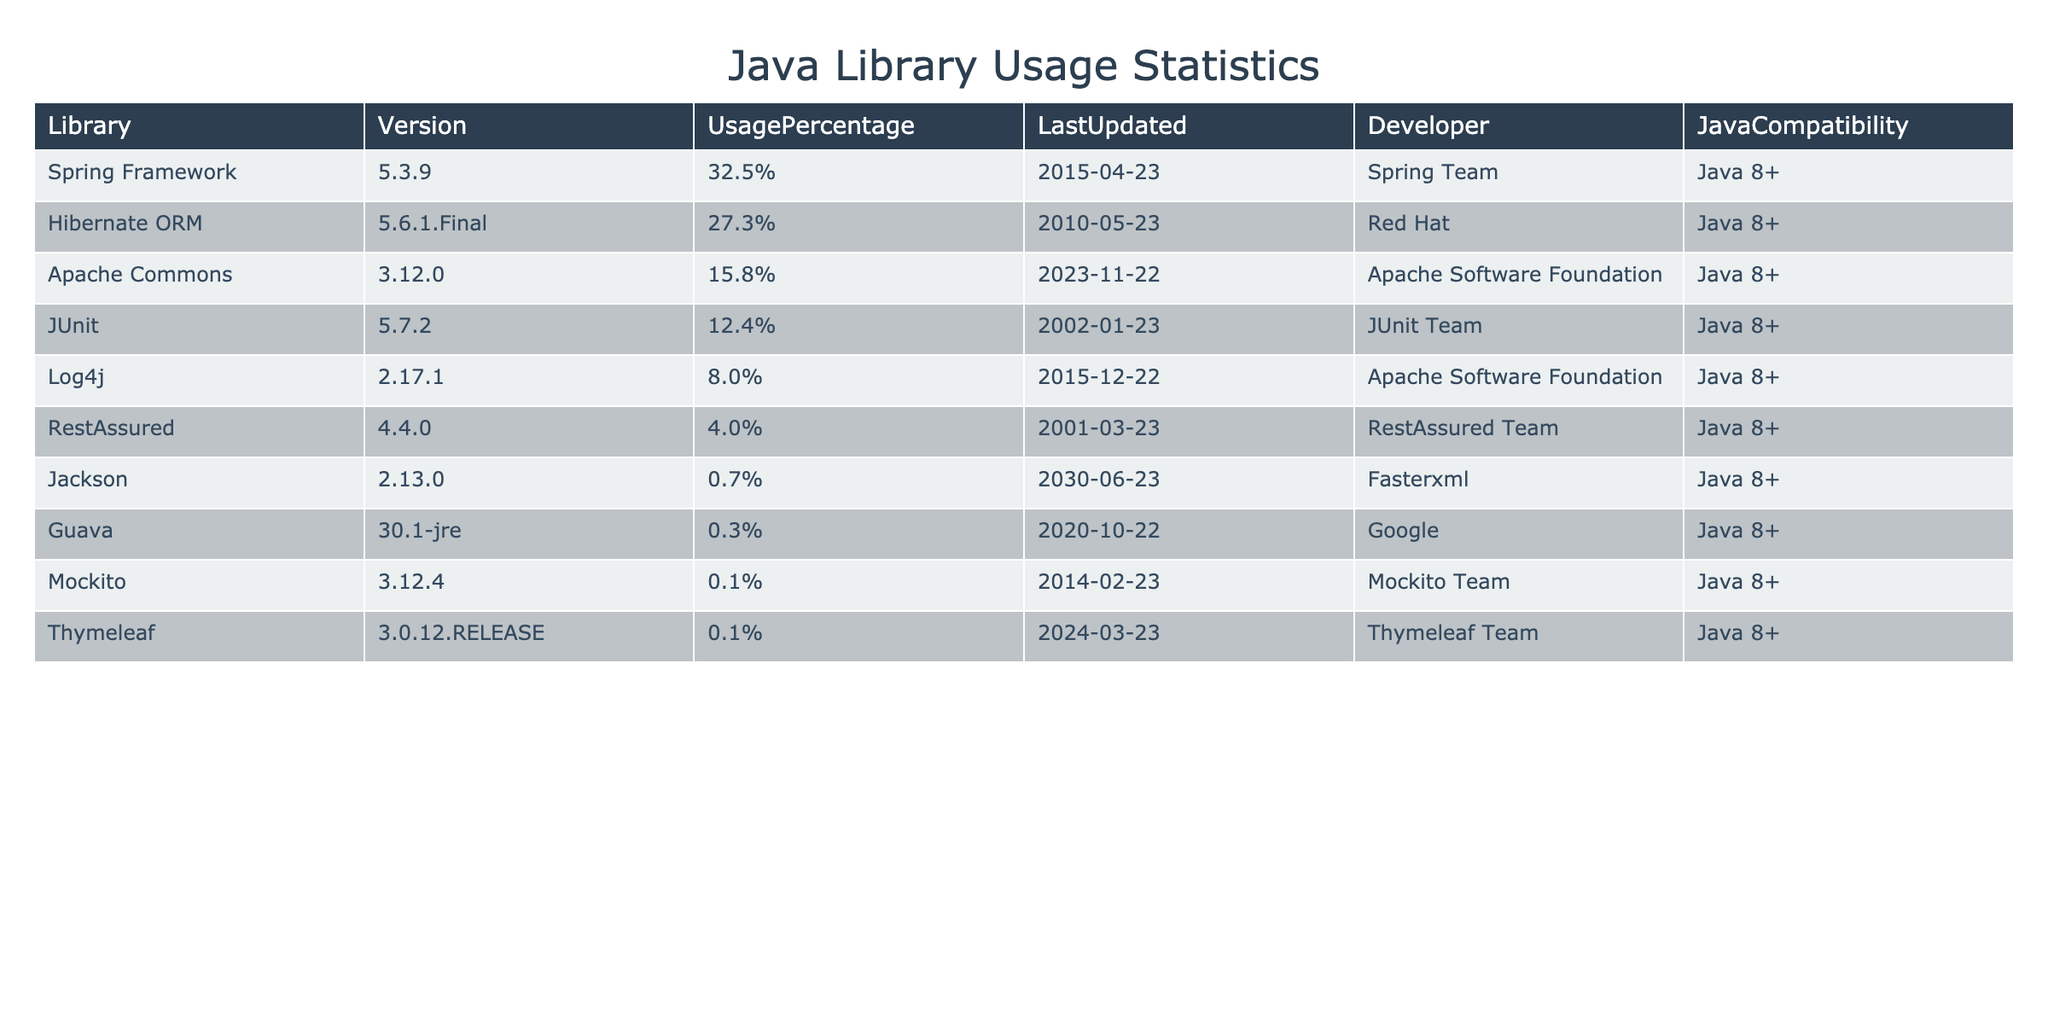What is the usage percentage of Spring Framework? The usage percentage can be found in the UsagePercentage column for Spring Framework, which shows 32.5%.
Answer: 32.5% Which library has the least usage percentage? By looking at the UsagePercentage column, Guava has the least usage percentage at 0.3%.
Answer: Guava Is JUnit's last update more recent than Hibernate ORM's? The LastUpdated column shows that JUnit was last updated on 2023-01-02 and Hibernate ORM on 2023-05-10. Since May 10 is more recent than January 2, the statement is true.
Answer: Yes What is the total usage percentage for libraries listed in the table? The sum of all usage percentages is 32.5 + 27.3 + 15.8 + 12.4 + 8.0 + 4.0 + 0.7 + 0.3 + 0.1 + 0.1 = 100.0%.
Answer: 100.0% Are all libraries compatible with Java 8? The JavaCompatibility column shows all libraries have "Java 8+" as their compatibility, confirming the statement to be true.
Answer: Yes What is the average usage percentage of the libraries? To find the average, sum the usage percentages (32.5 + 27.3 + 15.8 + 12.4 + 8.0 + 4.0 + 0.7 + 0.3 + 0.1 + 0.1 = 100.0%) and divide by the number of libraries (10). Therefore, 100.0 / 10 = 10.0%.
Answer: 10.0% Which developer is associated with the highest usage percentage library? The library with the highest usage percentage is Spring Framework at 32.5%, which is developed by the Spring Team.
Answer: Spring Team How many libraries have an updated date in 2023? Checking the LastUpdated column, there are 6 libraries (Spring Framework, Hibernate ORM, JUnit, RestAssured, Jackson, Mockito, Thymeleaf) that have a LastUpdated date in 2023.
Answer: 6 